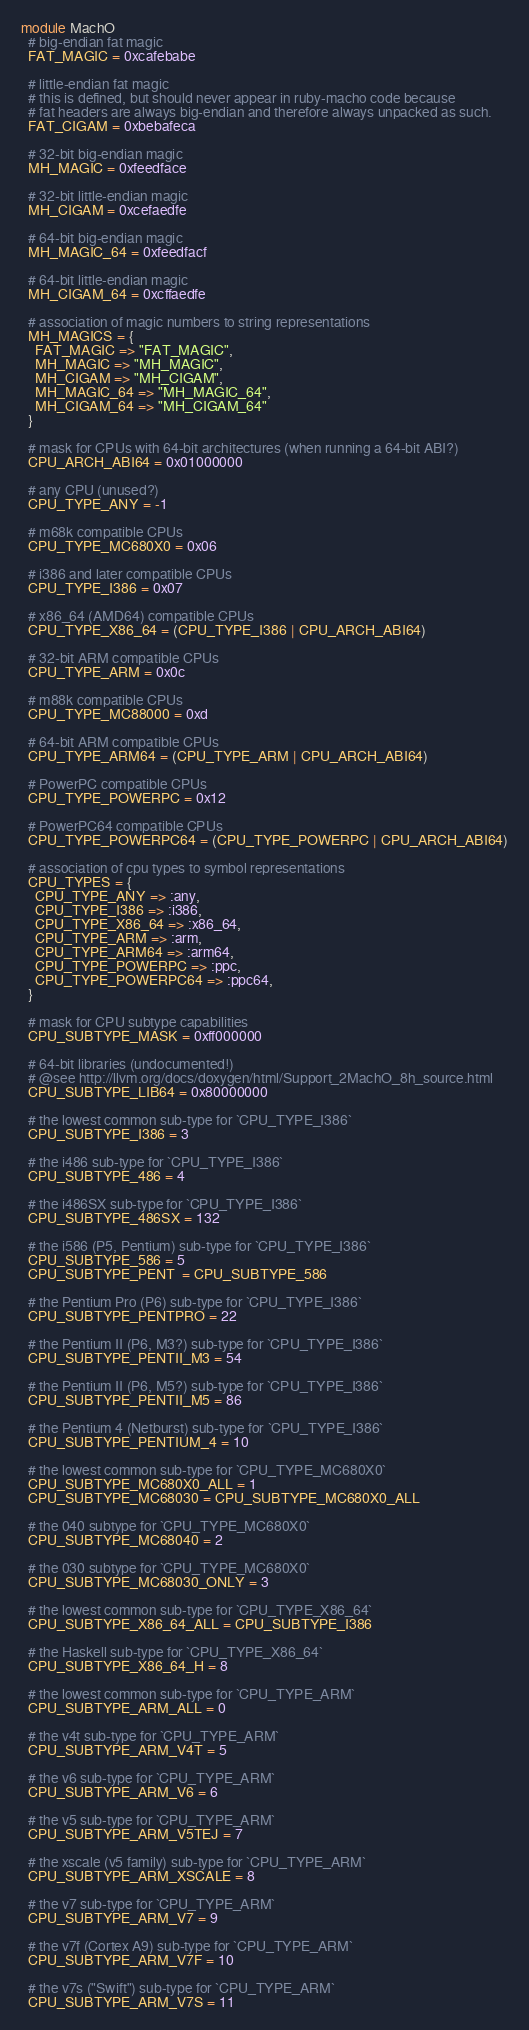Convert code to text. <code><loc_0><loc_0><loc_500><loc_500><_Ruby_>module MachO
  # big-endian fat magic
  FAT_MAGIC = 0xcafebabe

  # little-endian fat magic
  # this is defined, but should never appear in ruby-macho code because
  # fat headers are always big-endian and therefore always unpacked as such.
  FAT_CIGAM = 0xbebafeca

  # 32-bit big-endian magic
  MH_MAGIC = 0xfeedface

  # 32-bit little-endian magic
  MH_CIGAM = 0xcefaedfe

  # 64-bit big-endian magic
  MH_MAGIC_64 = 0xfeedfacf

  # 64-bit little-endian magic
  MH_CIGAM_64 = 0xcffaedfe

  # association of magic numbers to string representations
  MH_MAGICS = {
    FAT_MAGIC => "FAT_MAGIC",
    MH_MAGIC => "MH_MAGIC",
    MH_CIGAM => "MH_CIGAM",
    MH_MAGIC_64 => "MH_MAGIC_64",
    MH_CIGAM_64 => "MH_CIGAM_64"
  }

  # mask for CPUs with 64-bit architectures (when running a 64-bit ABI?)
  CPU_ARCH_ABI64 = 0x01000000

  # any CPU (unused?)
  CPU_TYPE_ANY = -1

  # m68k compatible CPUs
  CPU_TYPE_MC680X0 = 0x06

  # i386 and later compatible CPUs
  CPU_TYPE_I386 = 0x07

  # x86_64 (AMD64) compatible CPUs
  CPU_TYPE_X86_64 = (CPU_TYPE_I386 | CPU_ARCH_ABI64)

  # 32-bit ARM compatible CPUs
  CPU_TYPE_ARM = 0x0c

  # m88k compatible CPUs
  CPU_TYPE_MC88000 = 0xd

  # 64-bit ARM compatible CPUs
  CPU_TYPE_ARM64 = (CPU_TYPE_ARM | CPU_ARCH_ABI64)

  # PowerPC compatible CPUs
  CPU_TYPE_POWERPC = 0x12

  # PowerPC64 compatible CPUs
  CPU_TYPE_POWERPC64 = (CPU_TYPE_POWERPC | CPU_ARCH_ABI64)

  # association of cpu types to symbol representations
  CPU_TYPES = {
    CPU_TYPE_ANY => :any,
    CPU_TYPE_I386 => :i386,
    CPU_TYPE_X86_64 => :x86_64,
    CPU_TYPE_ARM => :arm,
    CPU_TYPE_ARM64 => :arm64,
    CPU_TYPE_POWERPC => :ppc,
    CPU_TYPE_POWERPC64 => :ppc64,
  }

  # mask for CPU subtype capabilities
  CPU_SUBTYPE_MASK = 0xff000000

  # 64-bit libraries (undocumented!)
  # @see http://llvm.org/docs/doxygen/html/Support_2MachO_8h_source.html
  CPU_SUBTYPE_LIB64 = 0x80000000

  # the lowest common sub-type for `CPU_TYPE_I386`
  CPU_SUBTYPE_I386 = 3

  # the i486 sub-type for `CPU_TYPE_I386`
  CPU_SUBTYPE_486 = 4

  # the i486SX sub-type for `CPU_TYPE_I386`
  CPU_SUBTYPE_486SX = 132

  # the i586 (P5, Pentium) sub-type for `CPU_TYPE_I386`
  CPU_SUBTYPE_586 = 5
  CPU_SUBTYPE_PENT  = CPU_SUBTYPE_586

  # the Pentium Pro (P6) sub-type for `CPU_TYPE_I386`
  CPU_SUBTYPE_PENTPRO = 22

  # the Pentium II (P6, M3?) sub-type for `CPU_TYPE_I386`
  CPU_SUBTYPE_PENTII_M3 = 54

  # the Pentium II (P6, M5?) sub-type for `CPU_TYPE_I386`
  CPU_SUBTYPE_PENTII_M5 = 86

  # the Pentium 4 (Netburst) sub-type for `CPU_TYPE_I386`
  CPU_SUBTYPE_PENTIUM_4 = 10

  # the lowest common sub-type for `CPU_TYPE_MC680X0`
  CPU_SUBTYPE_MC680X0_ALL = 1
  CPU_SUBTYPE_MC68030 = CPU_SUBTYPE_MC680X0_ALL

  # the 040 subtype for `CPU_TYPE_MC680X0`
  CPU_SUBTYPE_MC68040 = 2

  # the 030 subtype for `CPU_TYPE_MC680X0`
  CPU_SUBTYPE_MC68030_ONLY = 3

  # the lowest common sub-type for `CPU_TYPE_X86_64`
  CPU_SUBTYPE_X86_64_ALL = CPU_SUBTYPE_I386

  # the Haskell sub-type for `CPU_TYPE_X86_64`
  CPU_SUBTYPE_X86_64_H = 8

  # the lowest common sub-type for `CPU_TYPE_ARM`
  CPU_SUBTYPE_ARM_ALL = 0

  # the v4t sub-type for `CPU_TYPE_ARM`
  CPU_SUBTYPE_ARM_V4T = 5

  # the v6 sub-type for `CPU_TYPE_ARM`
  CPU_SUBTYPE_ARM_V6 = 6

  # the v5 sub-type for `CPU_TYPE_ARM`
  CPU_SUBTYPE_ARM_V5TEJ = 7

  # the xscale (v5 family) sub-type for `CPU_TYPE_ARM`
  CPU_SUBTYPE_ARM_XSCALE = 8

  # the v7 sub-type for `CPU_TYPE_ARM`
  CPU_SUBTYPE_ARM_V7 = 9

  # the v7f (Cortex A9) sub-type for `CPU_TYPE_ARM`
  CPU_SUBTYPE_ARM_V7F = 10

  # the v7s ("Swift") sub-type for `CPU_TYPE_ARM`
  CPU_SUBTYPE_ARM_V7S = 11
</code> 